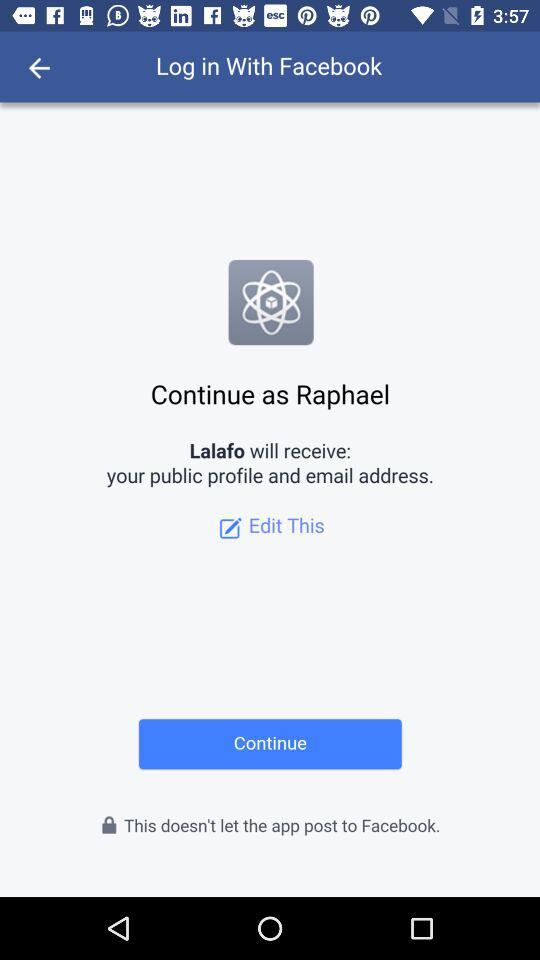What application is asking for permission? The application asking for permission is "Lalafo". 